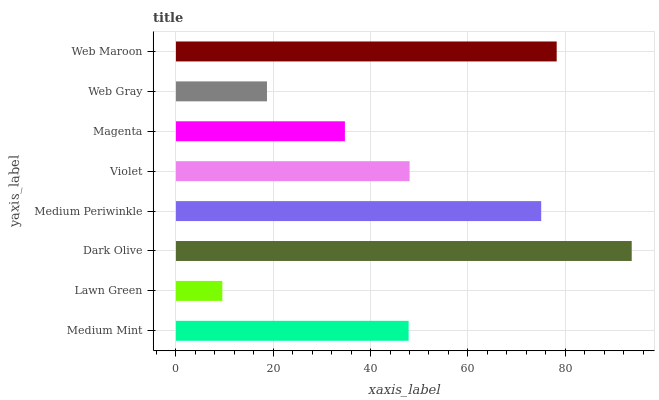Is Lawn Green the minimum?
Answer yes or no. Yes. Is Dark Olive the maximum?
Answer yes or no. Yes. Is Dark Olive the minimum?
Answer yes or no. No. Is Lawn Green the maximum?
Answer yes or no. No. Is Dark Olive greater than Lawn Green?
Answer yes or no. Yes. Is Lawn Green less than Dark Olive?
Answer yes or no. Yes. Is Lawn Green greater than Dark Olive?
Answer yes or no. No. Is Dark Olive less than Lawn Green?
Answer yes or no. No. Is Violet the high median?
Answer yes or no. Yes. Is Medium Mint the low median?
Answer yes or no. Yes. Is Medium Periwinkle the high median?
Answer yes or no. No. Is Violet the low median?
Answer yes or no. No. 